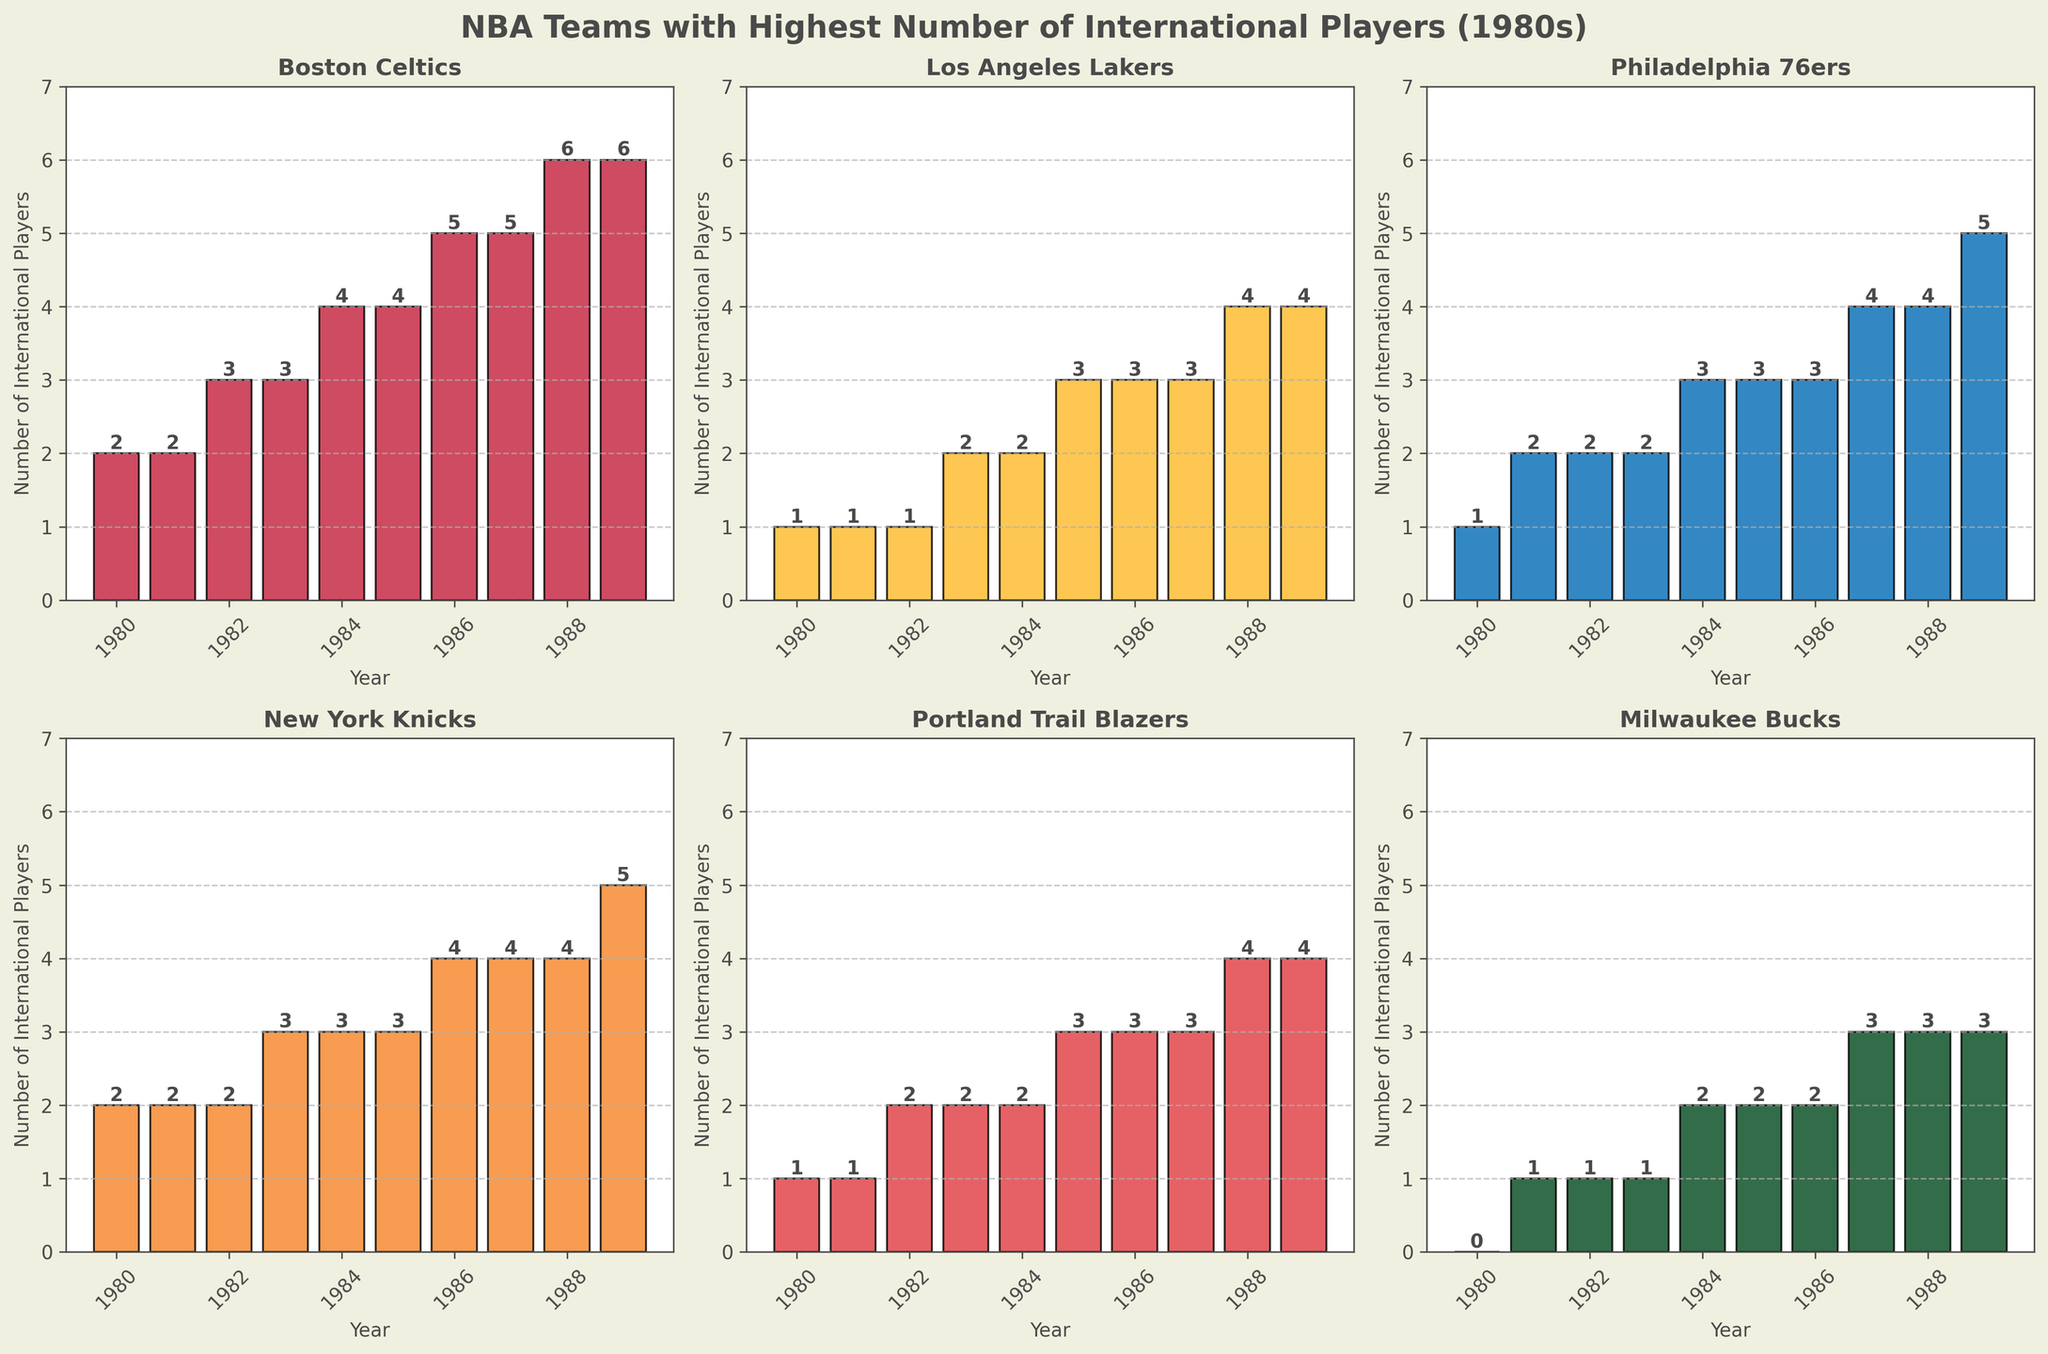Which team had the highest number of international players in 1980? Look at the bars for each team in the year 1980. The Boston Celtics and New York Knicks both have the highest number of international players, which is 2.
Answer: Boston Celtics, New York Knicks Which team showed a consistent increase in the number of international players from 1980 to 1989? Check each team’s bar heights from 1980 to 1989 to see if there's a consistent rising trend. The Boston Celtics steadily increase their number of international players every year.
Answer: Boston Celtics In 1983, which team had more international players, the Philadelphia 76ers or the New York Knicks? Compare the bar heights of Philadelphia 76ers and New York Knicks in 1983. The New York Knicks have 3 players, while the Philadelphia 76ers have 2.
Answer: New York Knicks What is the total number of international players in the Los Angeles Lakers from 1980 to 1989? Sum the number of international players for the Los Angeles Lakers for each year from 1980 to 1989: 1 + 1 + 1 + 2 + 2 + 3 + 3 + 3 + 4 + 4 = 24.
Answer: 24 Across the entire decade, which team ended with the highest number of international players in 1989? Look at the bars in 1989 for each team. The New York Knicks and Boston Celtics both have 6 players.
Answer: Boston Celtics, New York Knicks Which team had the largest increase in the number of international players from 1980 to 1989? Subtract the number of international players in 1980 from 1989 for each team:
- Boston Celtics: 6 - 2 = 4
- Los Angeles Lakers: 4 - 1 = 3
- Philadelphia 76ers: 5 - 1 = 4
- New York Knicks: 5 - 2 = 3
- Portland Trail Blazers: 4 - 1 = 3
- Milwaukee Bucks: 3 - 0 = 3
Both Boston Celtics and Philadelphia 76ers increased by 4 players.
Answer: Boston Celtics, Philadelphia 76ers In which year did the Milwaukee Bucks first reach 3 international players? Check each year for the Milwaukee Bucks to see when the bar height reaches 3. It reaches 3 in 1987.
Answer: 1987 